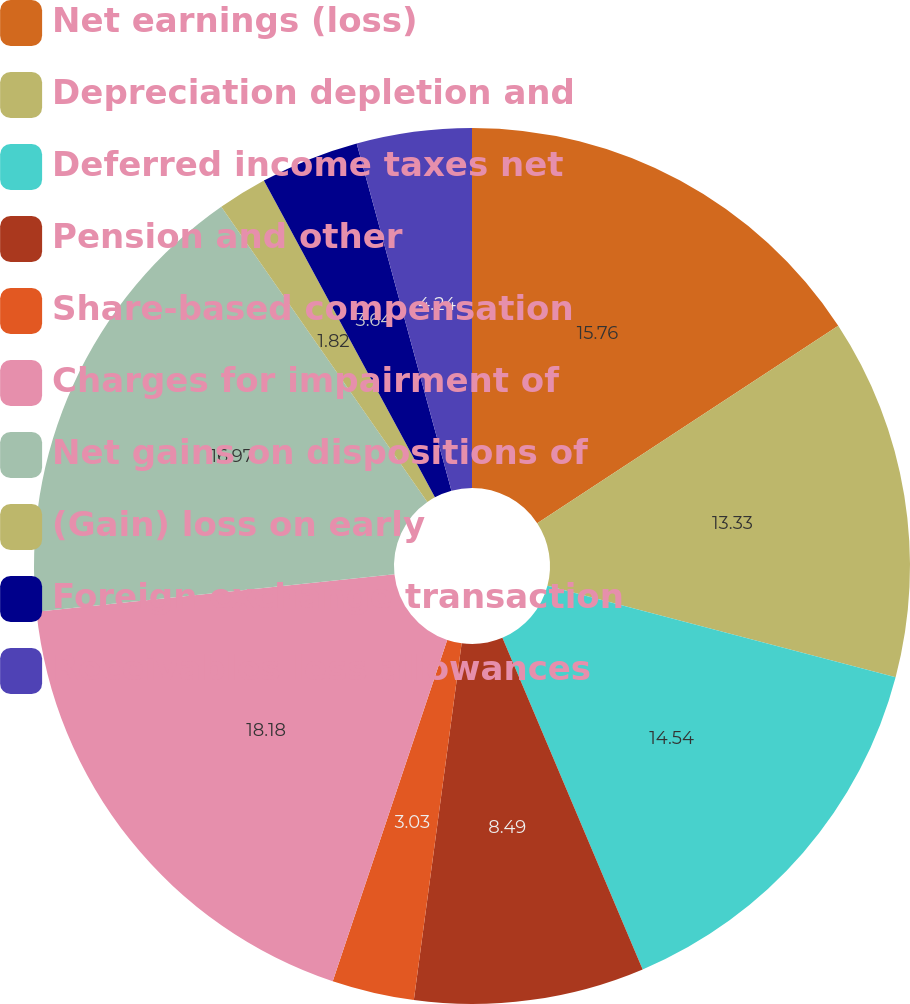Convert chart to OTSL. <chart><loc_0><loc_0><loc_500><loc_500><pie_chart><fcel>Net earnings (loss)<fcel>Depreciation depletion and<fcel>Deferred income taxes net<fcel>Pension and other<fcel>Share-based compensation<fcel>Charges for impairment of<fcel>Net gains on dispositions of<fcel>(Gain) loss on early<fcel>Foreign exchange transaction<fcel>Receivables less allowances<nl><fcel>15.76%<fcel>13.33%<fcel>14.54%<fcel>8.49%<fcel>3.03%<fcel>18.18%<fcel>16.97%<fcel>1.82%<fcel>3.64%<fcel>4.24%<nl></chart> 